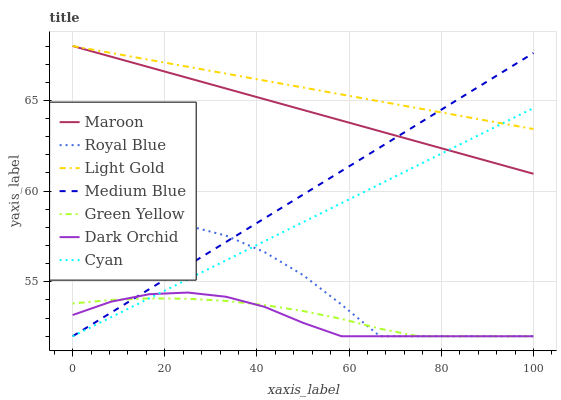Does Dark Orchid have the minimum area under the curve?
Answer yes or no. Yes. Does Light Gold have the maximum area under the curve?
Answer yes or no. Yes. Does Royal Blue have the minimum area under the curve?
Answer yes or no. No. Does Royal Blue have the maximum area under the curve?
Answer yes or no. No. Is Maroon the smoothest?
Answer yes or no. Yes. Is Royal Blue the roughest?
Answer yes or no. Yes. Is Dark Orchid the smoothest?
Answer yes or no. No. Is Dark Orchid the roughest?
Answer yes or no. No. Does Maroon have the lowest value?
Answer yes or no. No. Does Dark Orchid have the highest value?
Answer yes or no. No. Is Dark Orchid less than Light Gold?
Answer yes or no. Yes. Is Light Gold greater than Dark Orchid?
Answer yes or no. Yes. Does Dark Orchid intersect Light Gold?
Answer yes or no. No. 